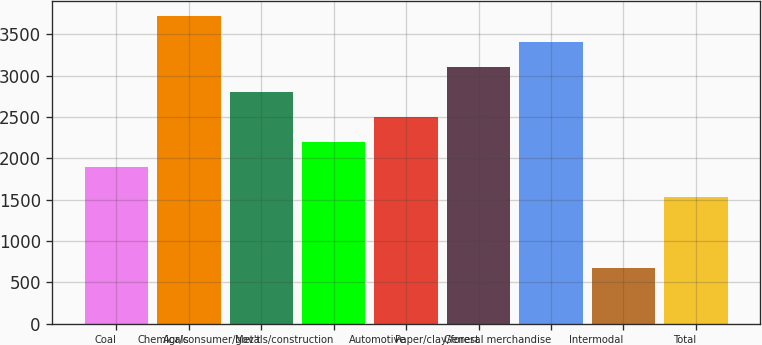Convert chart to OTSL. <chart><loc_0><loc_0><loc_500><loc_500><bar_chart><fcel>Coal<fcel>Chemicals<fcel>Agr/consumer/gov't<fcel>Metals/construction<fcel>Automotive<fcel>Paper/clay/forest<fcel>General merchandise<fcel>Intermodal<fcel>Total<nl><fcel>1888<fcel>3714.4<fcel>2801.2<fcel>2192.4<fcel>2496.8<fcel>3105.6<fcel>3410<fcel>667<fcel>1532<nl></chart> 